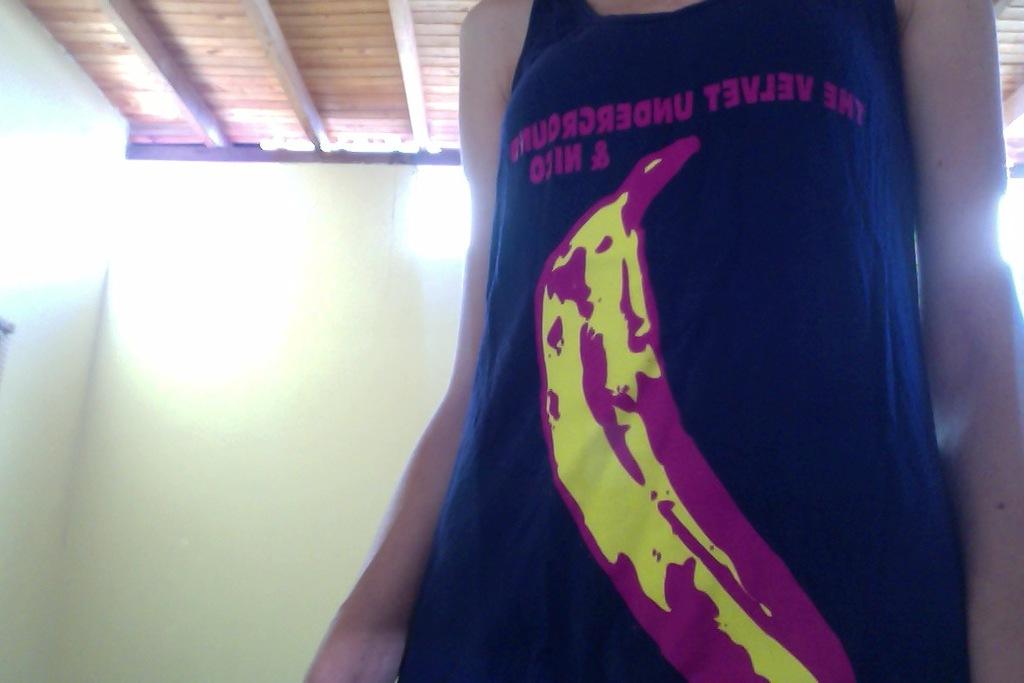What does the shirt say above the banana?
Offer a very short reply. The velvet underground. 